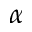<formula> <loc_0><loc_0><loc_500><loc_500>\alpha</formula> 